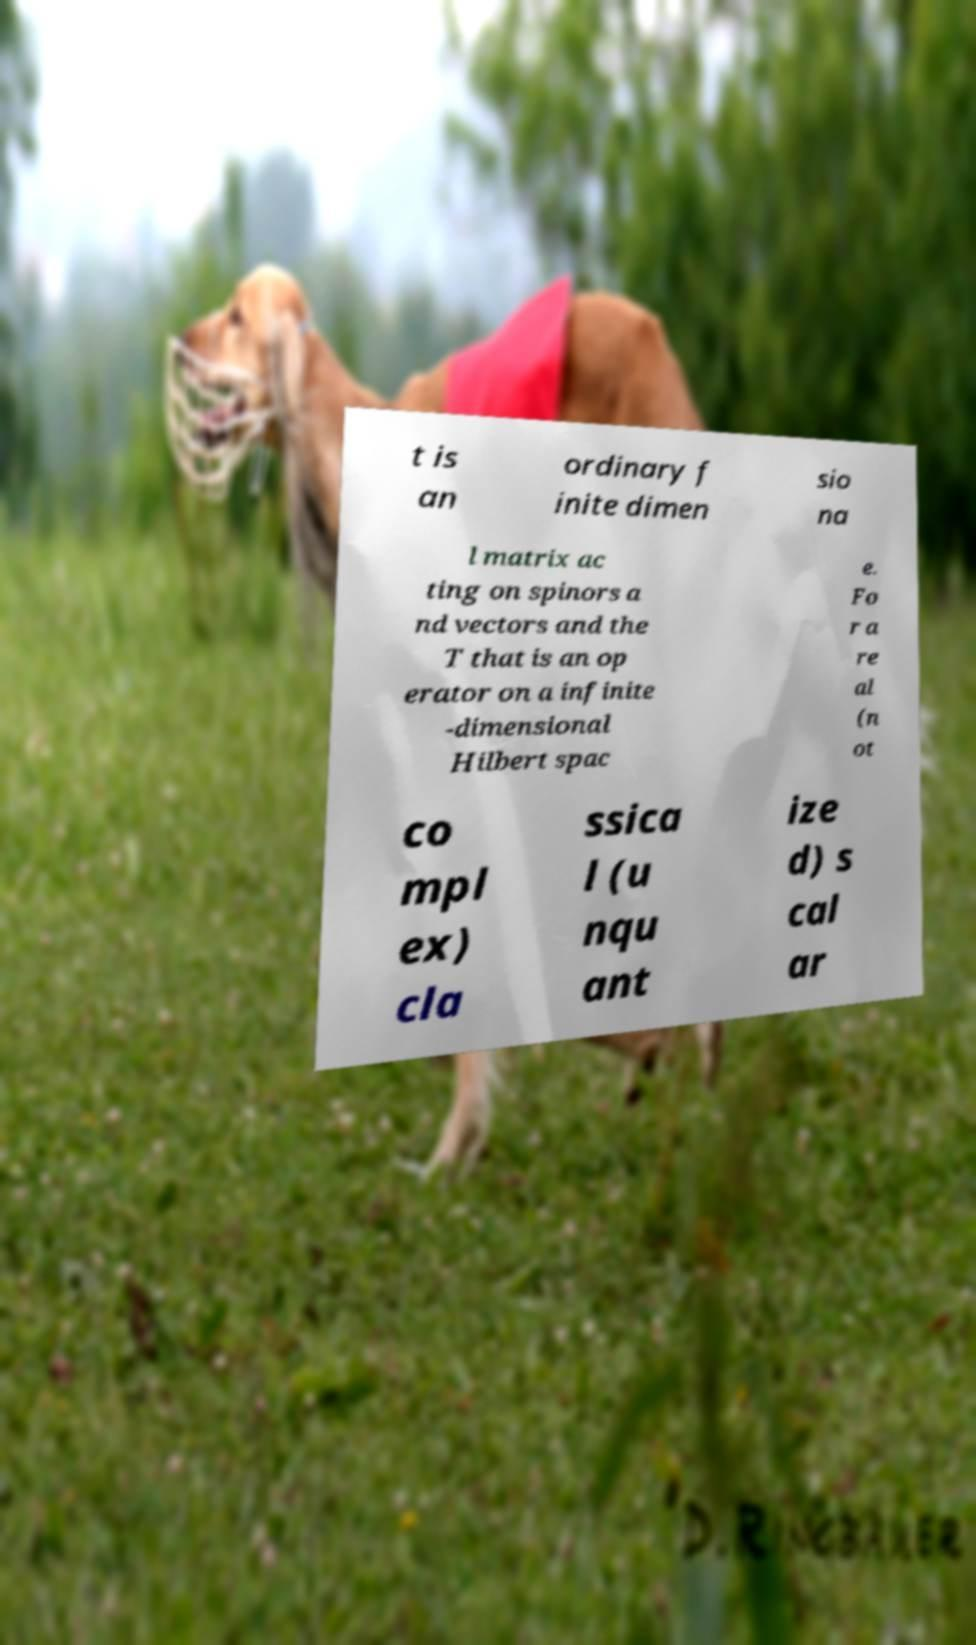Can you accurately transcribe the text from the provided image for me? t is an ordinary f inite dimen sio na l matrix ac ting on spinors a nd vectors and the T that is an op erator on a infinite -dimensional Hilbert spac e. Fo r a re al (n ot co mpl ex) cla ssica l (u nqu ant ize d) s cal ar 